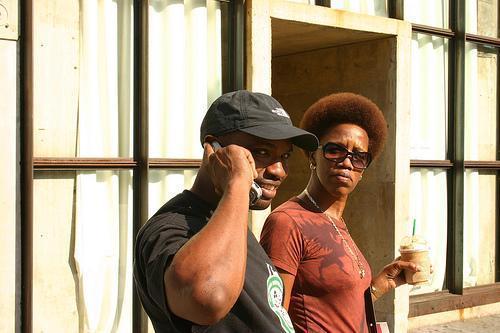How many people are there?
Give a very brief answer. 2. 